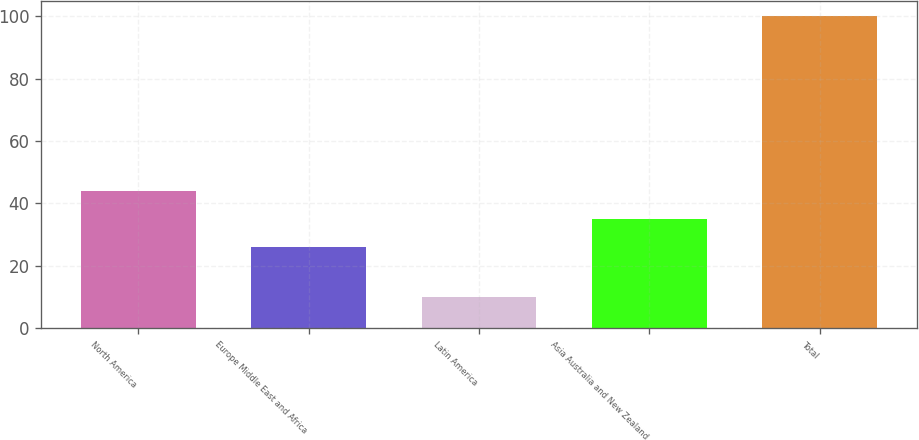Convert chart to OTSL. <chart><loc_0><loc_0><loc_500><loc_500><bar_chart><fcel>North America<fcel>Europe Middle East and Africa<fcel>Latin America<fcel>Asia Australia and New Zealand<fcel>Total<nl><fcel>44<fcel>26<fcel>10<fcel>35<fcel>100<nl></chart> 